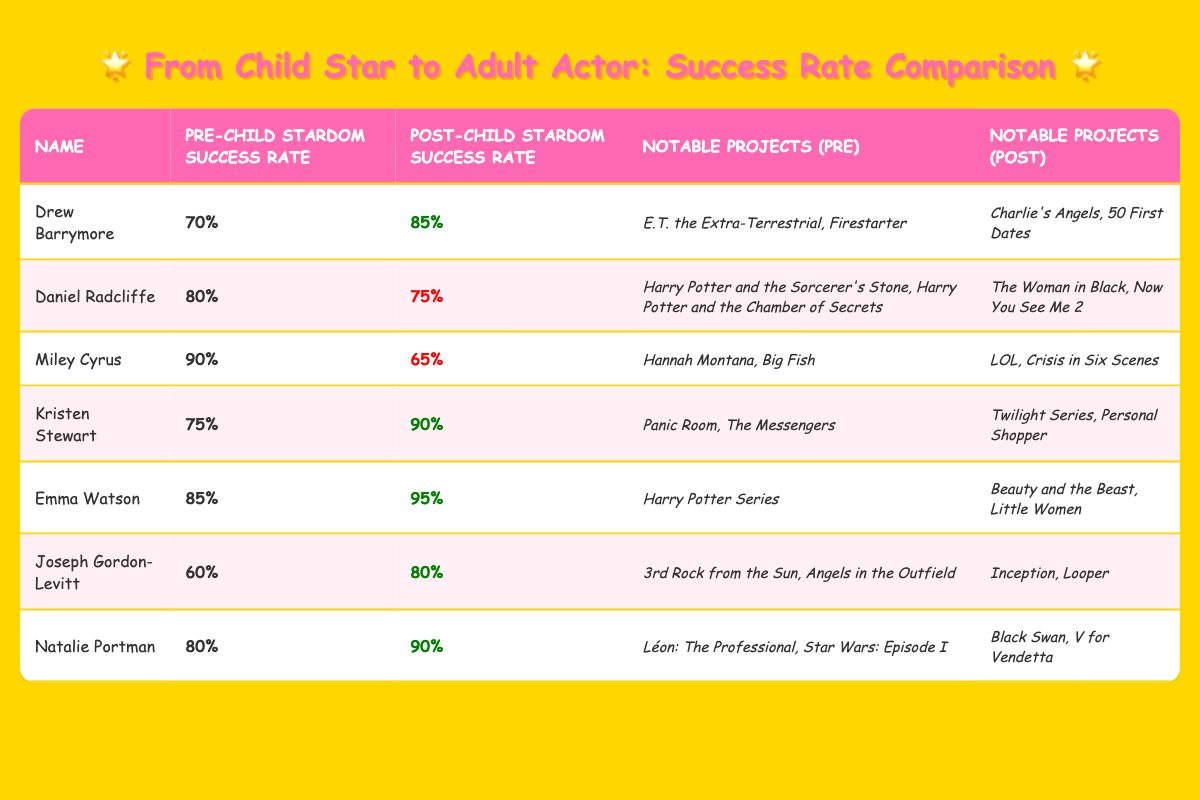What is Drew Barrymore's post-child stardom success rate? Drew Barrymore's post-child stardom success rate is listed in the table as 85%.
Answer: 85% Which child star had the highest pre-child stardom success rate? Miley Cyrus has the highest pre-child stardom success rate at 90%.
Answer: 90% What notable project did Emma Watson participate in before her child stardom? The table lists "Harry Potter Series" as a notable project for Emma Watson before her child stardom.
Answer: Harry Potter Series Which actor showed the greatest increase in success rate after child stardom? Drew Barrymore increased her success rate from 70% to 85%, which is an increase of 15 percentage points. No other actor has a larger increase.
Answer: Drew Barrymore Did any actors have a decrease in their post-child stardom success rate compared to pre-child stardom? Yes, Daniel Radcliffe and Miley Cyrus both experienced a decrease in their success rates after child stardom.
Answer: Yes What is the average pre-child stardom success rate for all the actors listed? Summing all the pre-child stardom success rates: 70 + 80 + 90 + 75 + 85 + 60 + 80 = 540. Dividing by 7 gives us an average of 540/7 = 77.14.
Answer: 77.14 Which child star has a post-child stardom success rate that is below 70%? The table shows that Miley Cyrus has a post-child stardom success rate of 65%, which is below 70%.
Answer: Miley Cyrus What is the difference between Emma Watson's pre-child stardom and post-child stardom success rates? Emma Watson's pre-child stardom success rate is 85% and her post-child stardom rate is 95%. The difference is 95 - 85 = 10 percentage points.
Answer: 10 Out of the actors listed, who has the lowest post-child stardom success rate? Miley Cyrus has the lowest post-child stardom success rate at 65%.
Answer: 65% Which two actors achieved a higher success rate after child stardom than before? Drew Barrymore and Emma Watson both achieved higher success rates after child stardom, with increases of 15% and 10%, respectively.
Answer: Drew Barrymore and Emma Watson 